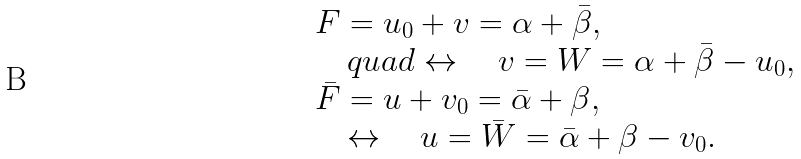<formula> <loc_0><loc_0><loc_500><loc_500>\begin{array} { l } F = u _ { 0 } + v = \alpha + \bar { \beta } , \\ \quad q u a d \leftrightarrow \quad v = W = \alpha + \bar { \beta } - u _ { 0 } , \\ \bar { F } = u + v _ { 0 } = \bar { \alpha } + \beta , \\ \quad \leftrightarrow \quad u = \bar { W } = \bar { \alpha } + \beta - v _ { 0 } . \end{array}</formula> 